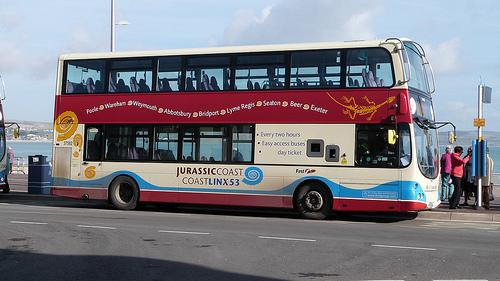Question: where was this photo taken?
Choices:
A. On the street.
B. A hockey game.
C. A parade.
D. A bar.
Answer with the letter. Answer: A Question: what is present?
Choices:
A. A bus.
B. A truck.
C. A bicycle.
D. A wagon.
Answer with the letter. Answer: A Question: who is present?
Choices:
A. An elderly man.
B. A beautiful woman.
C. A small child.
D. People.
Answer with the letter. Answer: D Question: what is it for?
Choices:
A. Delivery.
B. Transport.
C. Accommodation.
D. Sightseeing.
Answer with the letter. Answer: B 